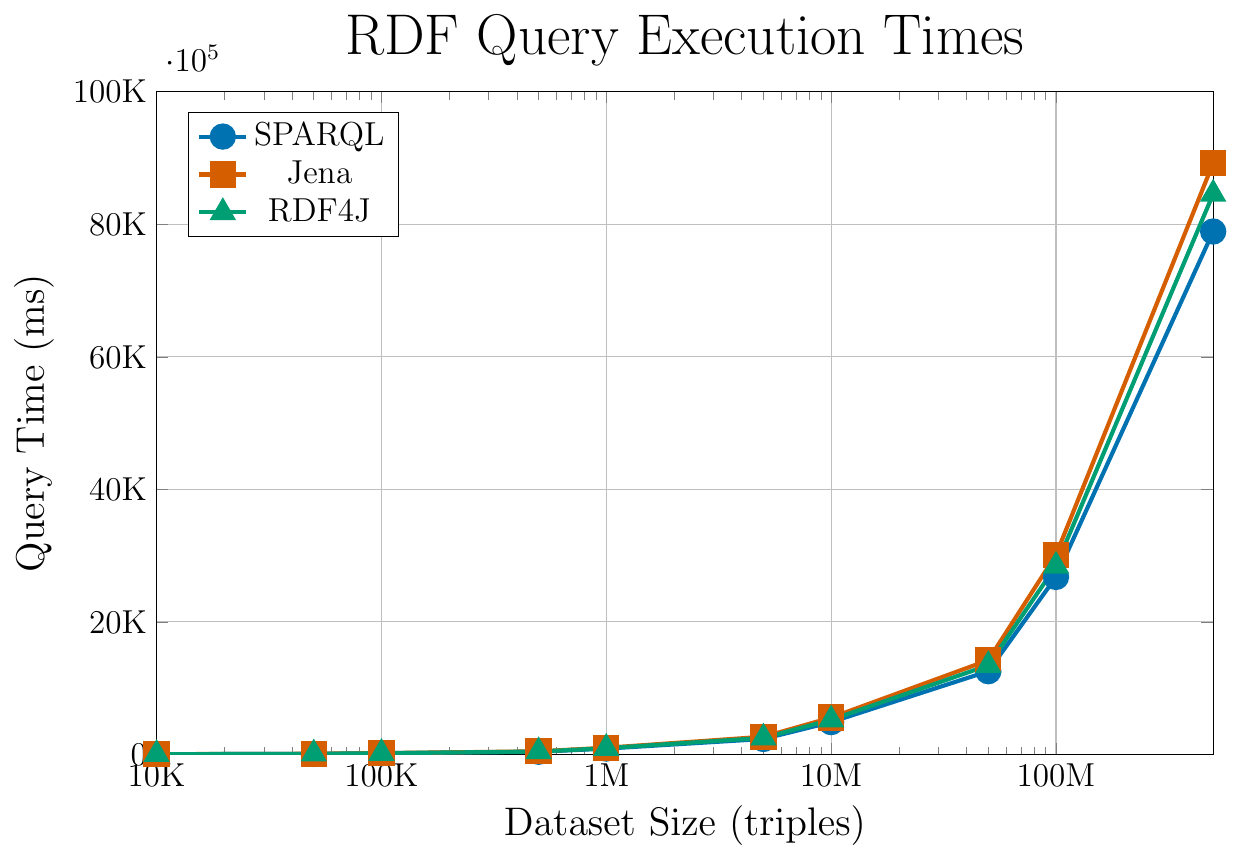What is the query time for RDF4J at a dataset size of 5,000,000 triples? Locate the RDF4J line (green, triangle markers) and find the coordinate point for 5,000,000 triples on the x-axis. The y-coordinate at this point indicates the query time.
Answer: 2512 ms Which system shows the highest query time for 1,000,000 triples? Find the query times at 1,000,000 triples for all three systems on the y-axis. Compare the values: SPARQL (895 ms), Jena (1023 ms), and RDF4J (962 ms).
Answer: Jena By how much does the query time for Jena increase when the dataset size steps from 10,000,000 triples to 50,000,000 triples? Subtract the query time at 10,000,000 triples (5,567 ms) from the query time at 50,000,000 triples (14,234 ms) for Jena.
Answer: 8,667 ms What is the average query time of all systems at 100,000 triples? Query times at 100,000 triples: SPARQL (187 ms), Jena (215 ms), RDF4J (201 ms). Calculate the average: (187 + 215 + 201) / 3.
Answer: 201 ms Which system exhibits a greater increase in query time from 100,000 triples to 500,000 triples, SPARQL or RDF4J? Compute the increase for SPARQL: 412 ms - 187 ms = 225 ms. Compute the increase for RDF4J: 445 ms - 201 ms = 244 ms. Compare the increases.
Answer: RDF4J At the maximum dataset size plotted (500 million triples), which system performs best, and what is the query time? Compare the query times at 500 million triples for all systems: SPARQL (78,901 ms), Jena (89,234 ms), RDF4J (84,567 ms). Identify the smallest value.
Answer: SPARQL, 78,901 ms What is the difference in query times between SPARQL and RDF4J at 10 million triples? Find the query times for SPARQL (4,890 ms) and RDF4J (5,234 ms) at 10 million triples. Subtract SPARQL's time from RDF4J's time.
Answer: 344 ms How much faster is RDF4J compared to Jena at 50,000 triples? Find the query times for RDF4J (105 ms) and Jena (112 ms) at 50,000 triples. Subtract RDF4J's time from Jena's time.
Answer: 7 ms Which system has the steepest slope in query time growth as dataset size increases and how do you determine this? A steeper slope is indicated by a faster increase in query time. Quantitatively, examining the total change over the range of dataset sizes is useful. Identify the system whose line increases the most sharply.
Answer: Jena By how much does the query time of SPARQL at 50,000 triples exceed that of SPARQL at 10,000 triples? Query times for SPARQL: 50,000 triples (98 ms) and 10,000 triples (45 ms). Subtract the time at 10,000 triples from that at 50,000 triples.
Answer: 53 ms 